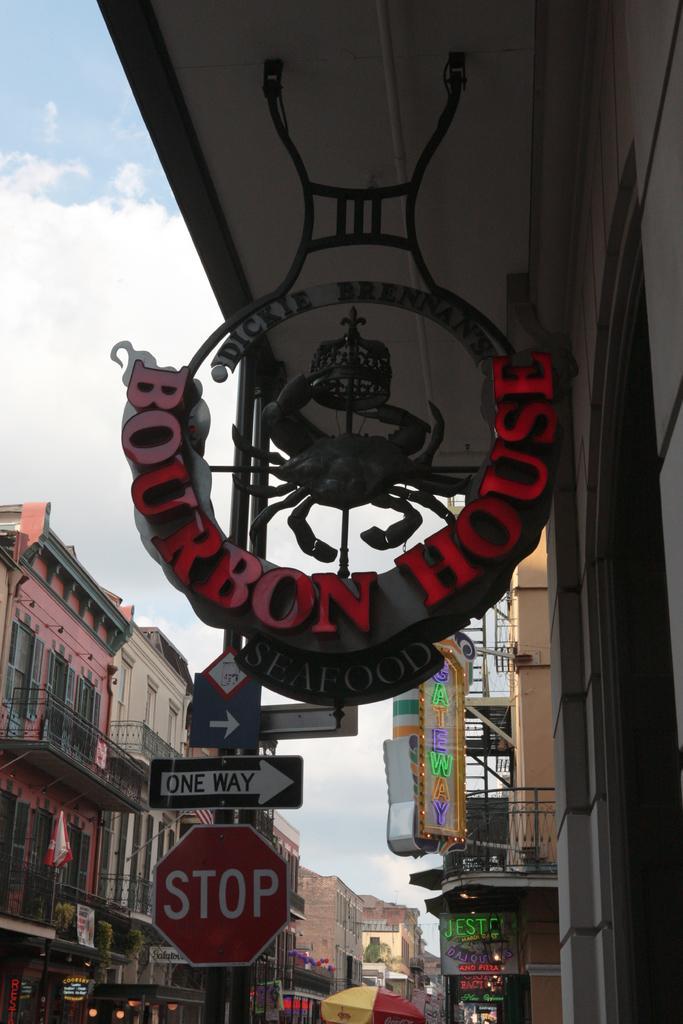Describe this image in one or two sentences. In this picture we can see boards, poles, wall and statue of a scorpion. In the background of the image we can see buildings, umbrella, boards, banner, lights, railings and sky with clouds. 